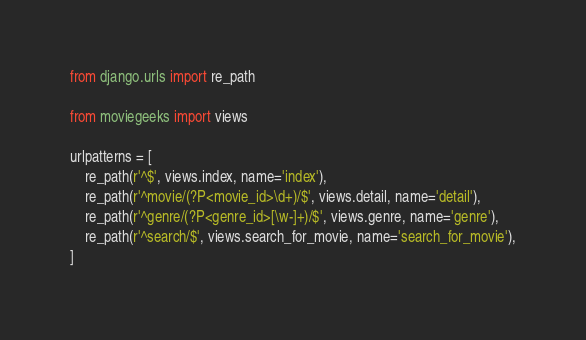<code> <loc_0><loc_0><loc_500><loc_500><_Python_>from django.urls import re_path

from moviegeeks import views

urlpatterns = [
    re_path(r'^$', views.index, name='index'),
    re_path(r'^movie/(?P<movie_id>\d+)/$', views.detail, name='detail'),
    re_path(r'^genre/(?P<genre_id>[\w-]+)/$', views.genre, name='genre'),
    re_path(r'^search/$', views.search_for_movie, name='search_for_movie'),
]
</code> 